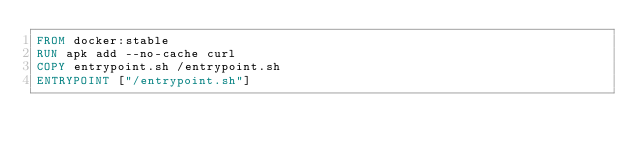<code> <loc_0><loc_0><loc_500><loc_500><_Dockerfile_>FROM docker:stable
RUN apk add --no-cache curl
COPY entrypoint.sh /entrypoint.sh
ENTRYPOINT ["/entrypoint.sh"]</code> 